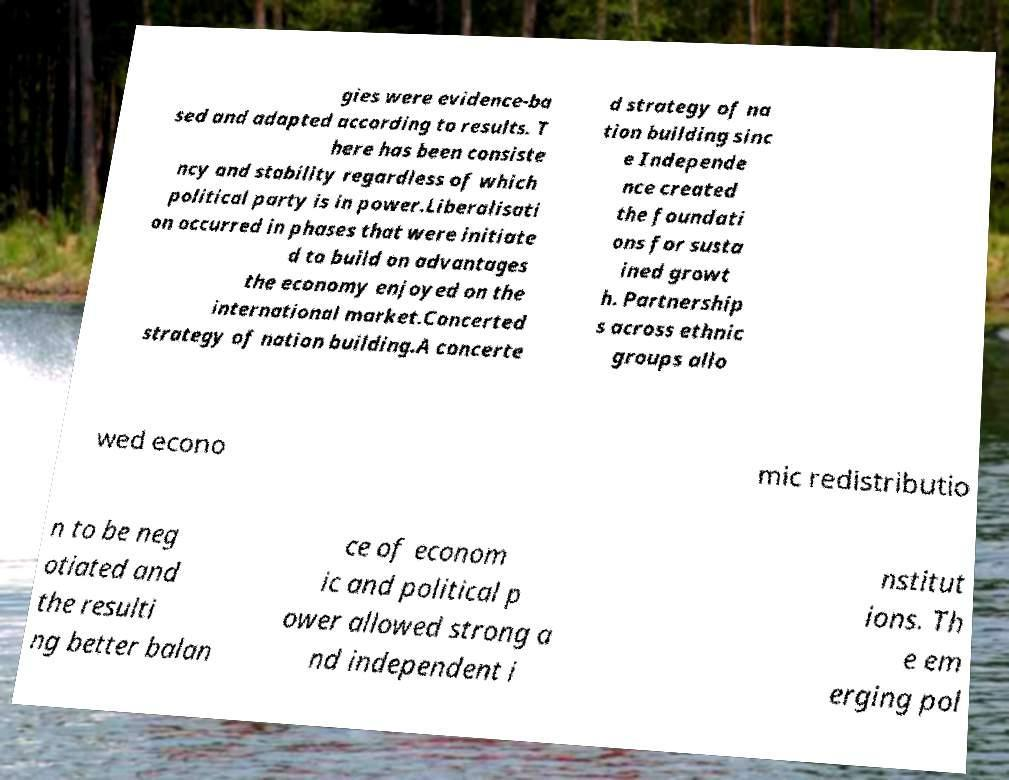For documentation purposes, I need the text within this image transcribed. Could you provide that? gies were evidence-ba sed and adapted according to results. T here has been consiste ncy and stability regardless of which political party is in power.Liberalisati on occurred in phases that were initiate d to build on advantages the economy enjoyed on the international market.Concerted strategy of nation building.A concerte d strategy of na tion building sinc e Independe nce created the foundati ons for susta ined growt h. Partnership s across ethnic groups allo wed econo mic redistributio n to be neg otiated and the resulti ng better balan ce of econom ic and political p ower allowed strong a nd independent i nstitut ions. Th e em erging pol 